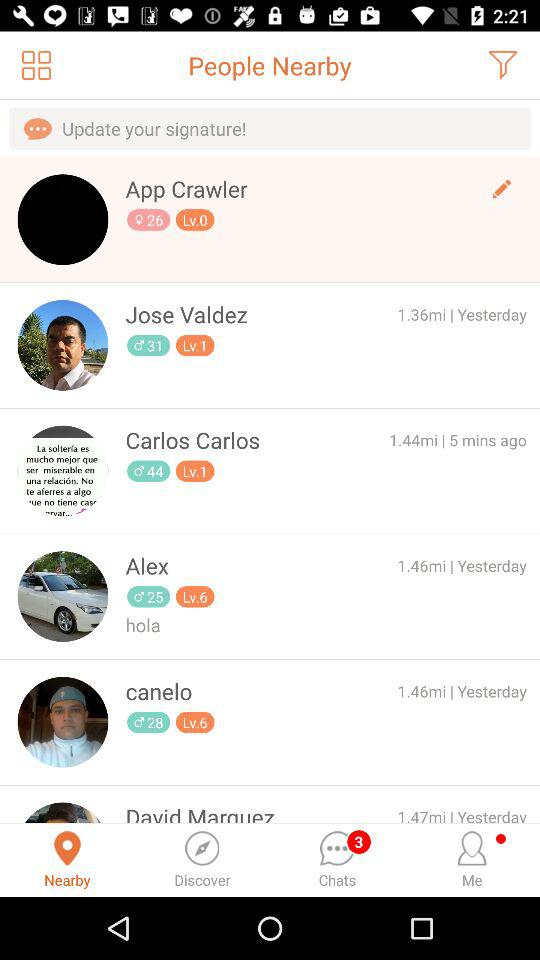Which tab is selected right now? Right now, the selected tab is "Nearby". 